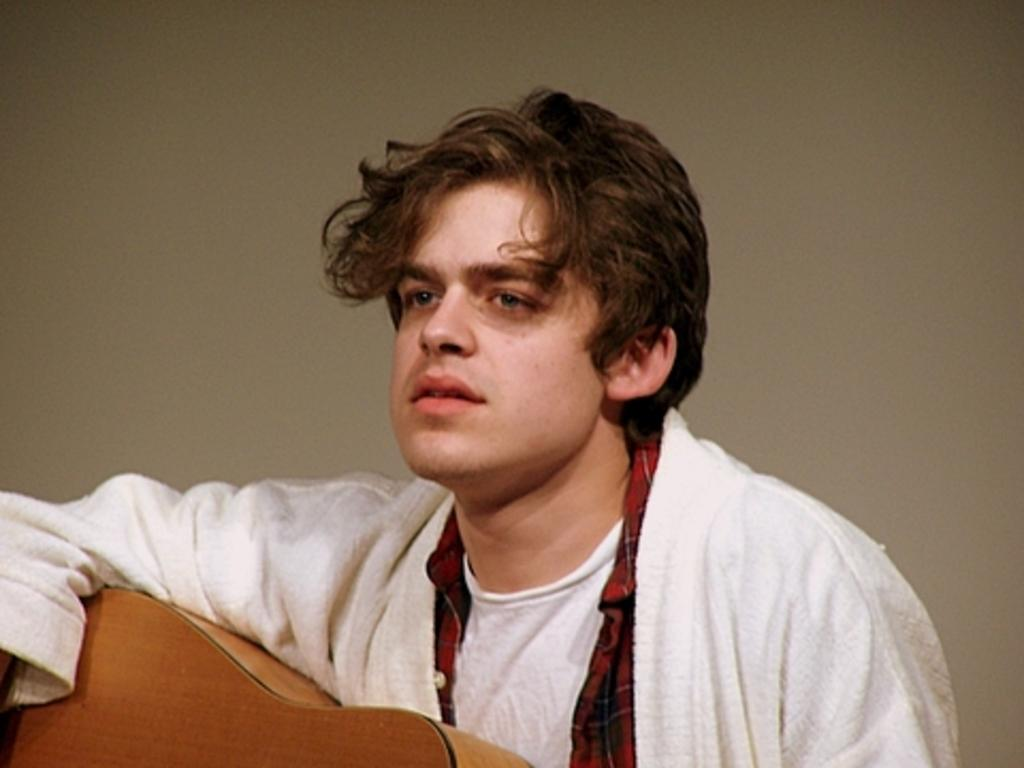Who is present in the image? There is a man in the image. What is the man wearing? The man is wearing a white jacket. What object is the man holding? The man is holding a guitar. What type of volleyball is the man playing in the image? There is no volleyball present in the image; the man is holding a guitar. How much payment is the man receiving for playing the guitar in the image? There is no indication of payment in the image; it only shows the man holding a guitar. 